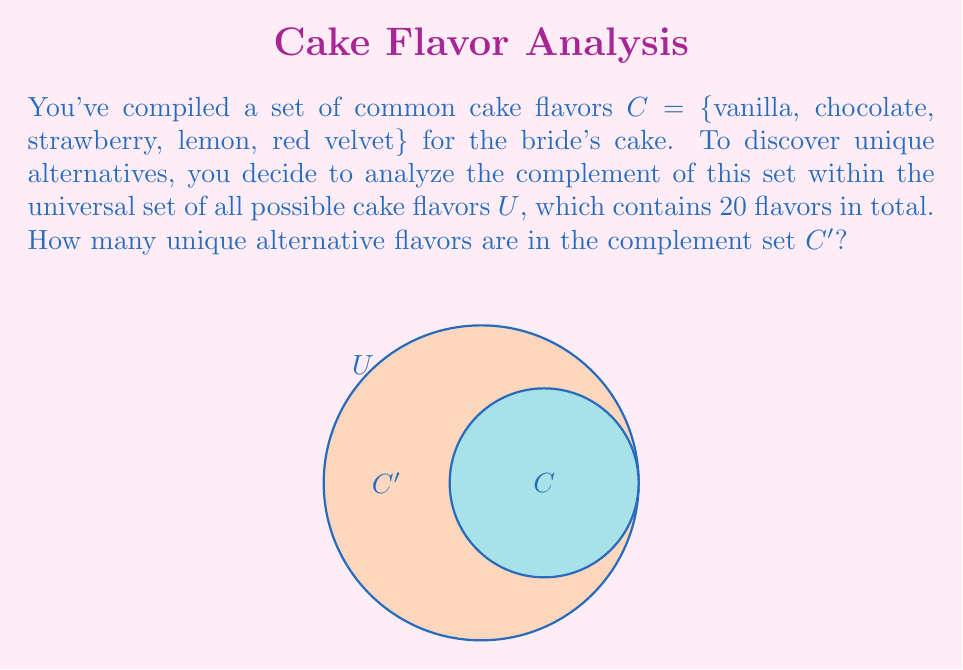Can you answer this question? To solve this problem, we'll use the concept of set complement and cardinality:

1) The universal set $U$ contains all possible cake flavors. We're given that $|U| = 20$.

2) Set $C$ contains the common cake flavors, and we can count that $|C| = 5$.

3) The complement of set $C$, denoted as $C'$, contains all elements in $U$ that are not in $C$.

4) A fundamental property of set theory states that for any set $A$ within a universal set $U$:

   $$|A| + |A'| = |U|$$

5) Applying this to our problem:

   $$|C| + |C'| = |U|$$

6) Substituting the known values:

   $$5 + |C'| = 20$$

7) Solving for $|C'|$:

   $$|C'| = 20 - 5 = 15$$

Therefore, there are 15 unique alternative flavors in the complement set $C'$.
Answer: 15 